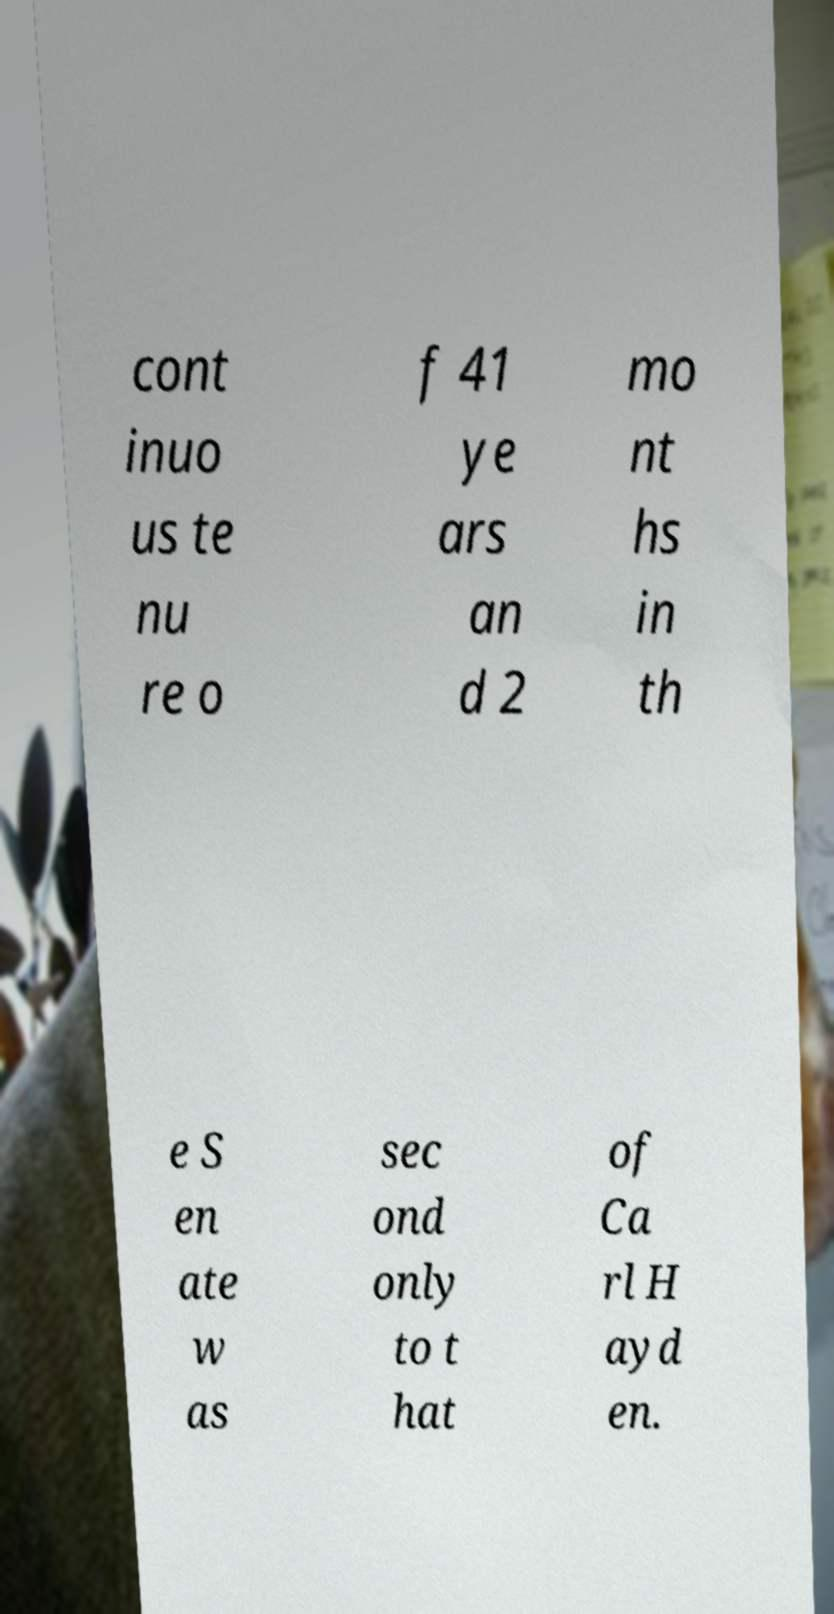I need the written content from this picture converted into text. Can you do that? cont inuo us te nu re o f 41 ye ars an d 2 mo nt hs in th e S en ate w as sec ond only to t hat of Ca rl H ayd en. 